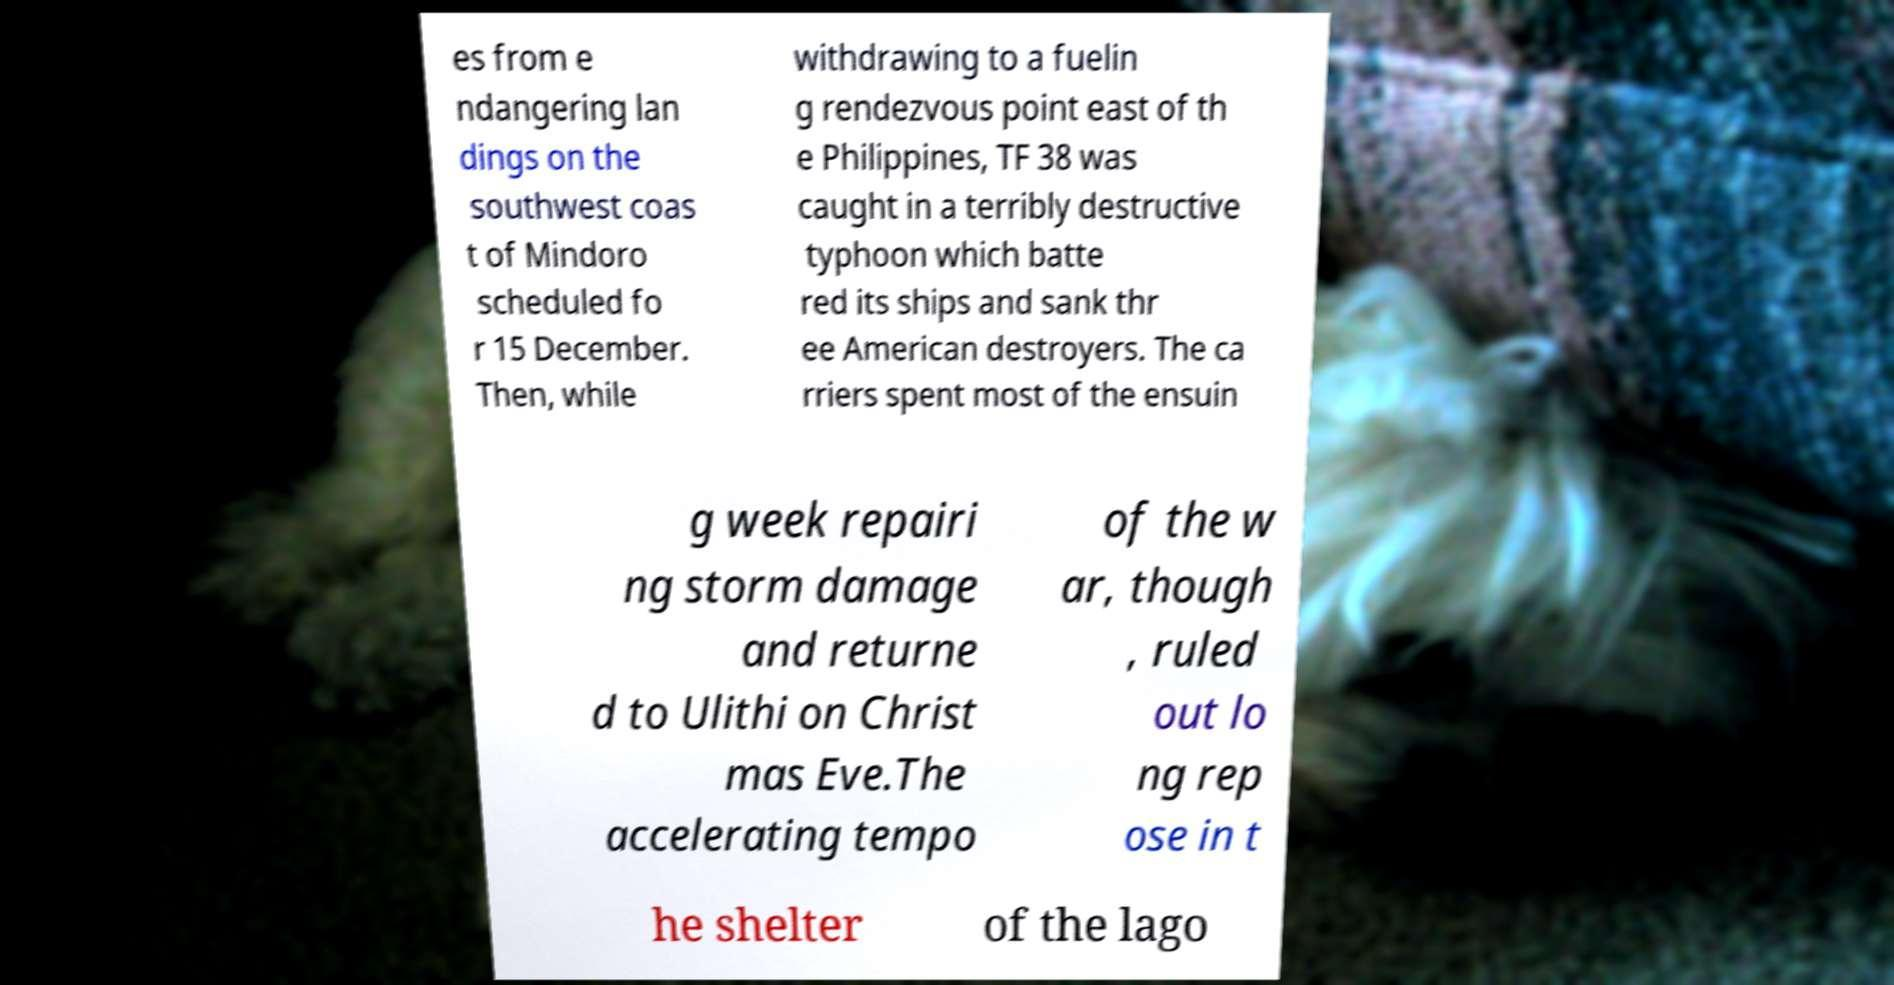Please read and relay the text visible in this image. What does it say? es from e ndangering lan dings on the southwest coas t of Mindoro scheduled fo r 15 December. Then, while withdrawing to a fuelin g rendezvous point east of th e Philippines, TF 38 was caught in a terribly destructive typhoon which batte red its ships and sank thr ee American destroyers. The ca rriers spent most of the ensuin g week repairi ng storm damage and returne d to Ulithi on Christ mas Eve.The accelerating tempo of the w ar, though , ruled out lo ng rep ose in t he shelter of the lago 